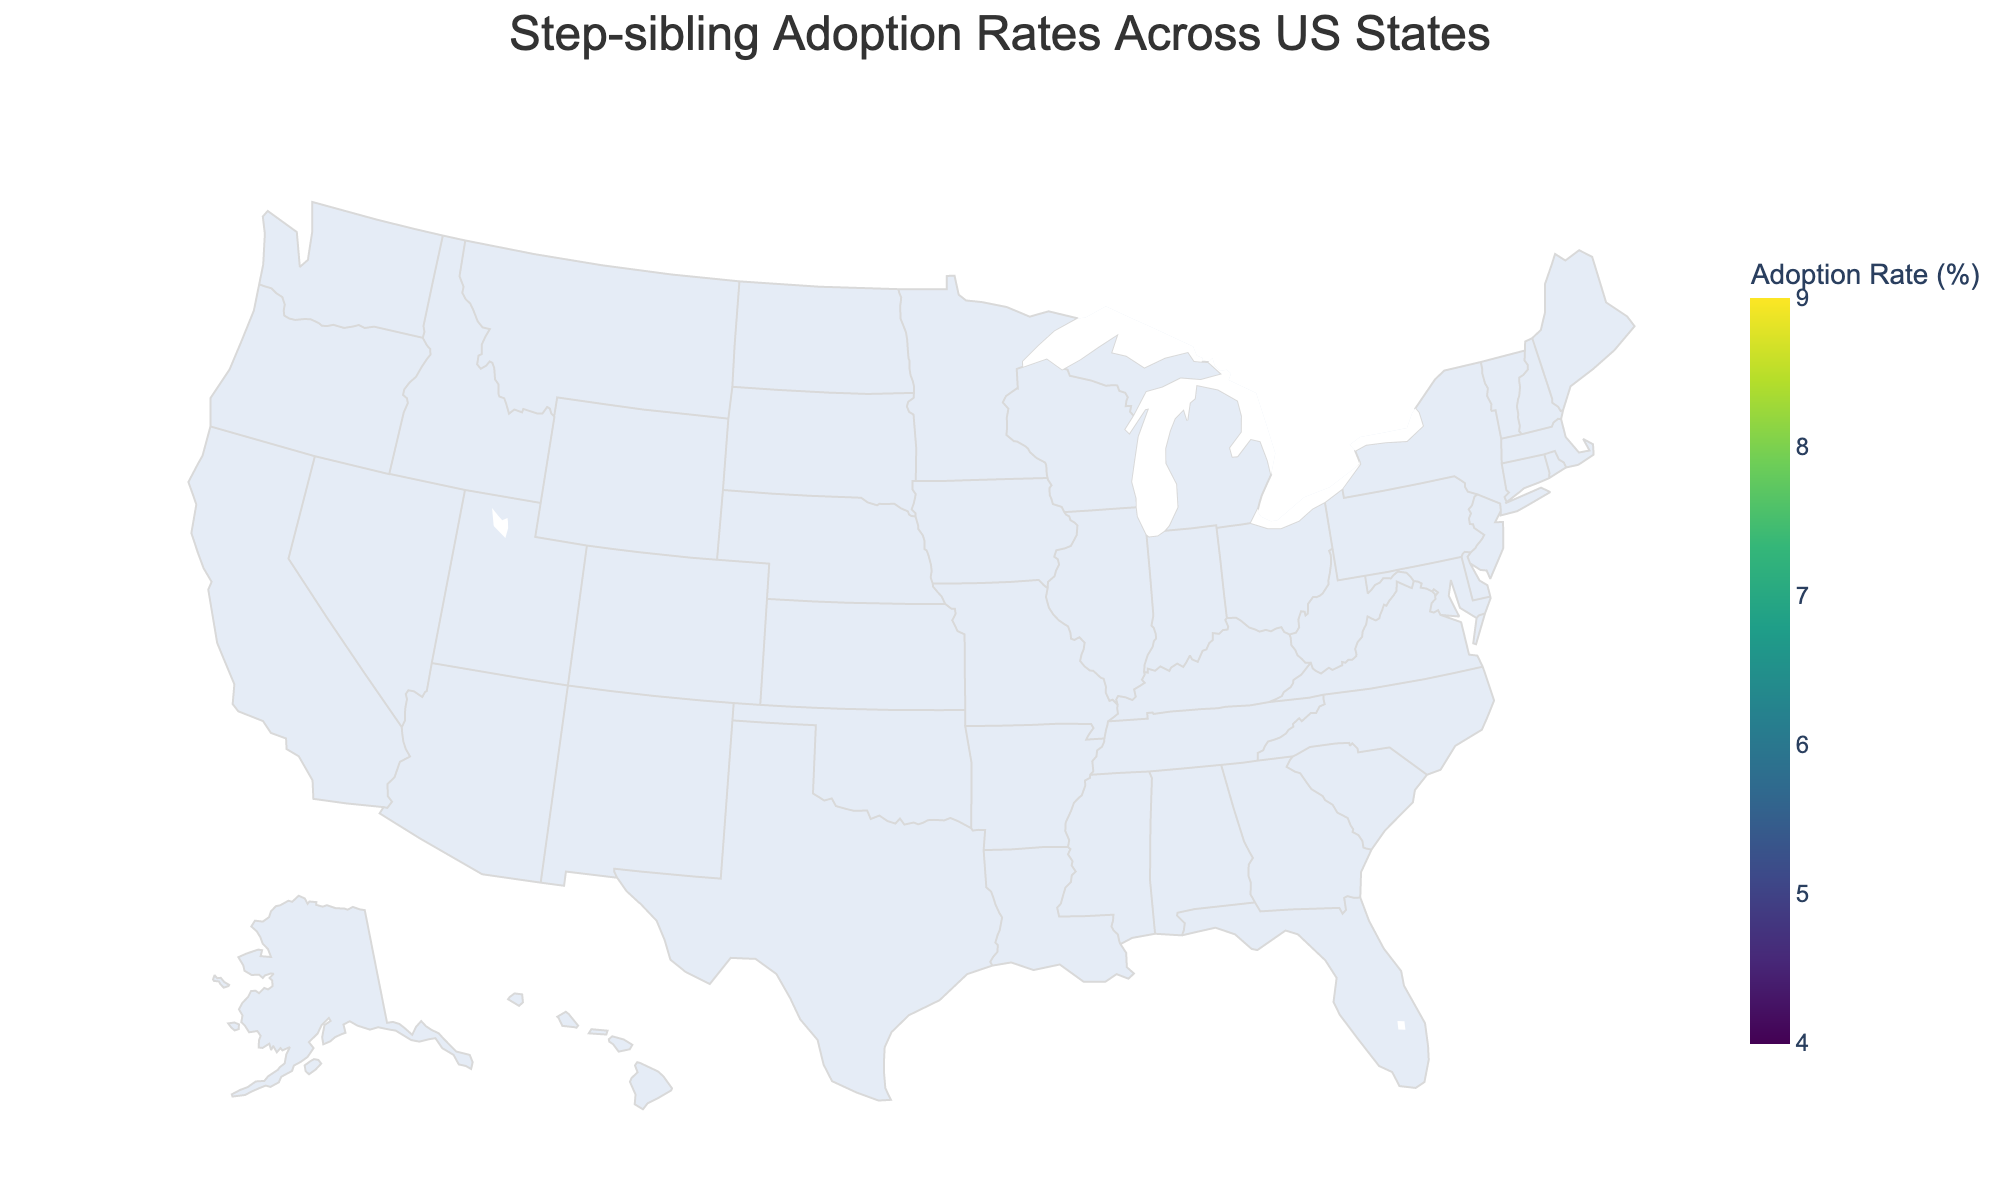Is there any state with a step-sibling adoption rate above 8%? Looking at the color gradient and data presented, we can see that California has a step-sibling adoption rate above 8% (8.2%).
Answer: Yes, California What is the range of step-sibling adoption rates depicted on the map? The choropleth map uses a color scale from 4% to 9%, so the range is 9% - 4% = 5%.
Answer: 5% Which state has the lowest step-sibling adoption rate? By analyzing the color gradient and data, Ohio has the lowest rate at 4.8%.
Answer: Ohio Which states have a step-sibling adoption rate between 6.5% and 7.5%? Evaluating the data, Florida, Georgia, Arizona, and Tennessee fit within this range.
Answer: Florida, Georgia, Arizona, Tennessee How many states have a step-sibling adoption rate over 7%? We need to count the states from the data with a rate above 7%: California, Florida, Washington, Arizona, Colorado. There are 5 states.
Answer: 5 What is the average step-sibling adoption rate for states on the west coast (California and Washington)? Summing up the rates for California (8.2%) and Washington (7.8%), we get 16%. Dividing by 2 states, the average is 8%.
Answer: 8% Compare the step-sibling adoption rates of New York and Pennsylvania. Which one is higher? By checking the data, we see New York has a rate of 5.9% and Pennsylvania has 5.1%, so New York is higher.
Answer: New York Which region (east or west of the Mississippi River) shows generally higher step-sibling adoption rates based on the states given? States like California, Washington, and Colorado in the west have high rates (>7%) while many eastern states (e.g., New York, Pennsylvania) have rates below 7%. The west shows higher rates.
Answer: West Are there any northeastern states with a step-sibling adoption rate above 6%? Checking the northeastern states in the data: New York (5.9%), Massachusetts (5.4%), and Pennsylvania (5.1%) all are below 6%.
Answer: No What is the difference in step-sibling adoption rates between Texas and Ohio? Texas has a rate of 6.7%, and Ohio has 4.8%. The difference is 6.7% - 4.8% = 1.9%.
Answer: 1.9% 